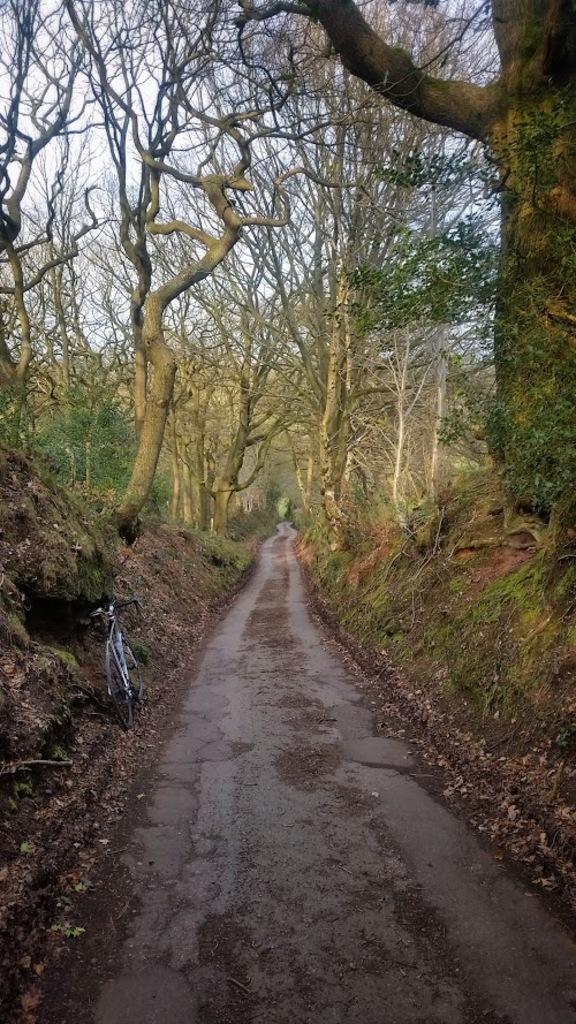What is the main feature in the middle of the image? There is a path or way in the middle of the image. What can be seen on either side of the path? There are big trees on either side of the path. How many cars can be seen parked along the path in the image? There are no cars visible in the image; it only features a path and big trees on either side. Is there a tiger hiding behind one of the trees in the image? There is no tiger present in the image; only the path and big trees are visible. 